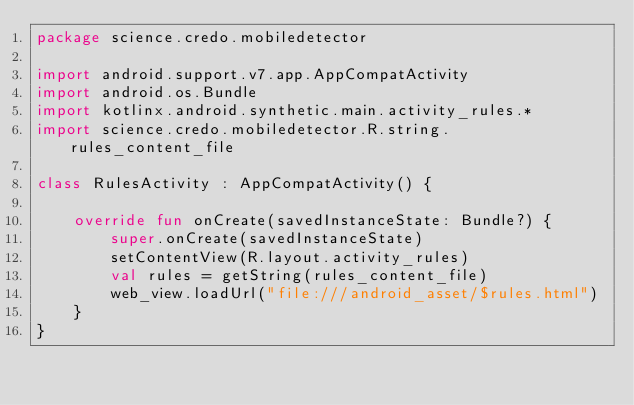<code> <loc_0><loc_0><loc_500><loc_500><_Kotlin_>package science.credo.mobiledetector

import android.support.v7.app.AppCompatActivity
import android.os.Bundle
import kotlinx.android.synthetic.main.activity_rules.*
import science.credo.mobiledetector.R.string.rules_content_file

class RulesActivity : AppCompatActivity() {

    override fun onCreate(savedInstanceState: Bundle?) {
        super.onCreate(savedInstanceState)
        setContentView(R.layout.activity_rules)
        val rules = getString(rules_content_file)
        web_view.loadUrl("file:///android_asset/$rules.html")
    }
}
</code> 